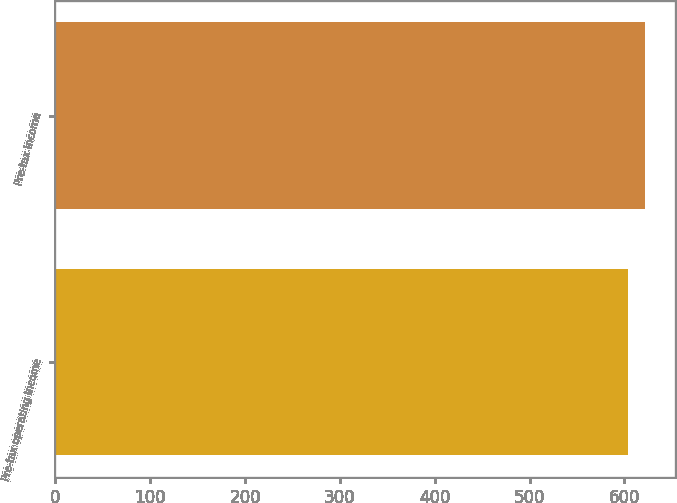<chart> <loc_0><loc_0><loc_500><loc_500><bar_chart><fcel>Pre-tax operating income<fcel>Pre-tax income<nl><fcel>604<fcel>622<nl></chart> 